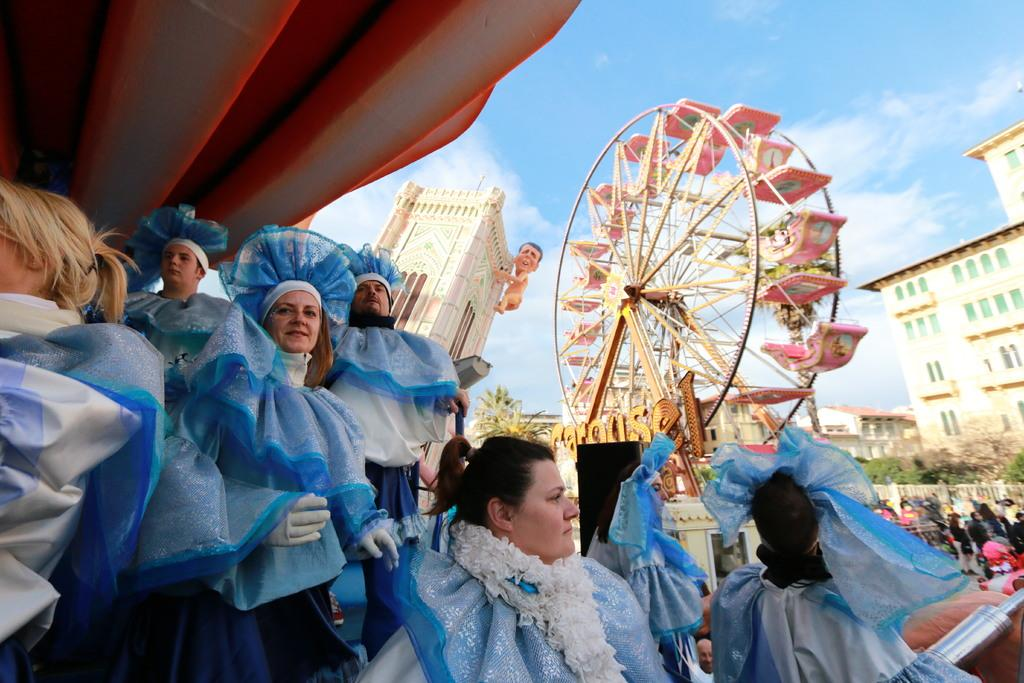How many people are in the group visible in the image? There is a group of people in the image, but the exact number is not specified. What type of object is in the image? There is a joint wheel in the image. What else can be seen in the image besides the group of people and the joint wheel? There are objects, a statue of a man, trees, buildings, and the sky visible in the image. What type of locket is the man wearing around his neck in the image? There is no man wearing a locket around his neck in the image; the statue of a man does not have any accessories. How many giants are present in the image? There are no giants present in the image; the statue of a man is not a giant. 